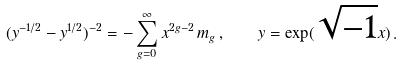<formula> <loc_0><loc_0><loc_500><loc_500>( y ^ { - 1 / 2 } - y ^ { 1 / 2 } ) ^ { - 2 } = - \sum _ { g = 0 } ^ { \infty } x ^ { 2 g - 2 } \, m _ { g } \, , \quad y = \exp ( \sqrt { - 1 } x ) \, .</formula> 